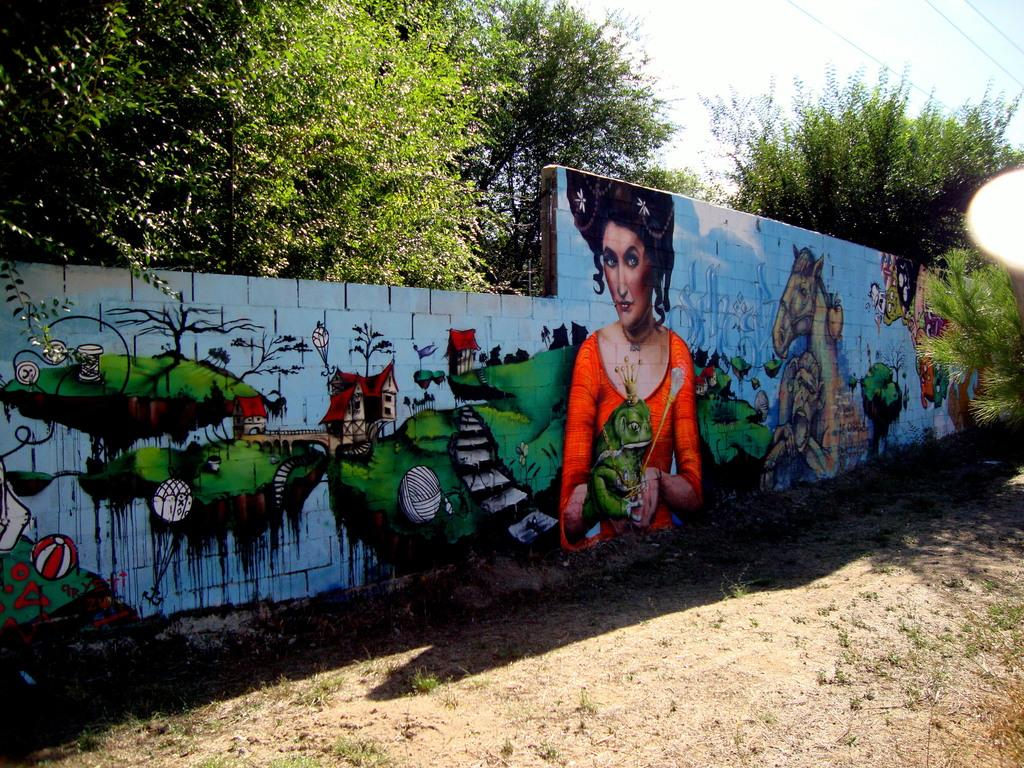What is present on the wall in the image? The wall is painted with different types of images. What specific images can be seen on the wall? The images include trees and houses. What else can be seen in the background of the image? There are trees and the sky is clear and visible in the background of the image. How many spiders are crawling on the wall in the image? There are no spiders present on the wall in the image. What type of stamp can be seen on the trees in the background? There are no stamps visible on the trees in the background of the image. 